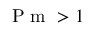Convert formula to latex. <formula><loc_0><loc_0><loc_500><loc_500>P m > 1</formula> 